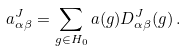Convert formula to latex. <formula><loc_0><loc_0><loc_500><loc_500>a _ { \alpha \beta } ^ { J } = \sum _ { g \in H _ { 0 } } a ( g ) D _ { \alpha \beta } ^ { J } ( g ) \, .</formula> 